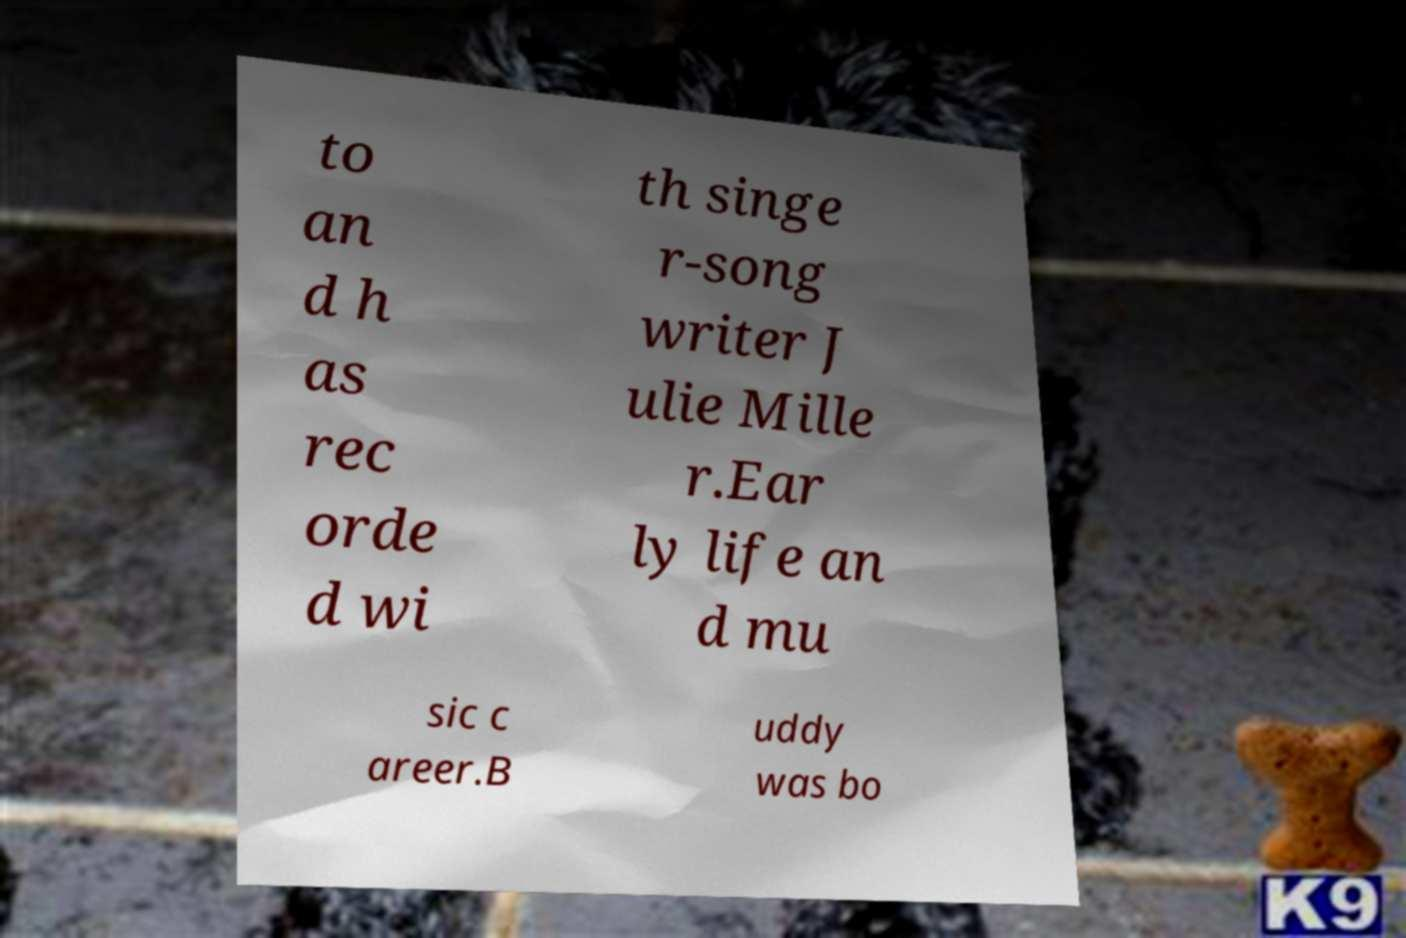Could you extract and type out the text from this image? to an d h as rec orde d wi th singe r-song writer J ulie Mille r.Ear ly life an d mu sic c areer.B uddy was bo 